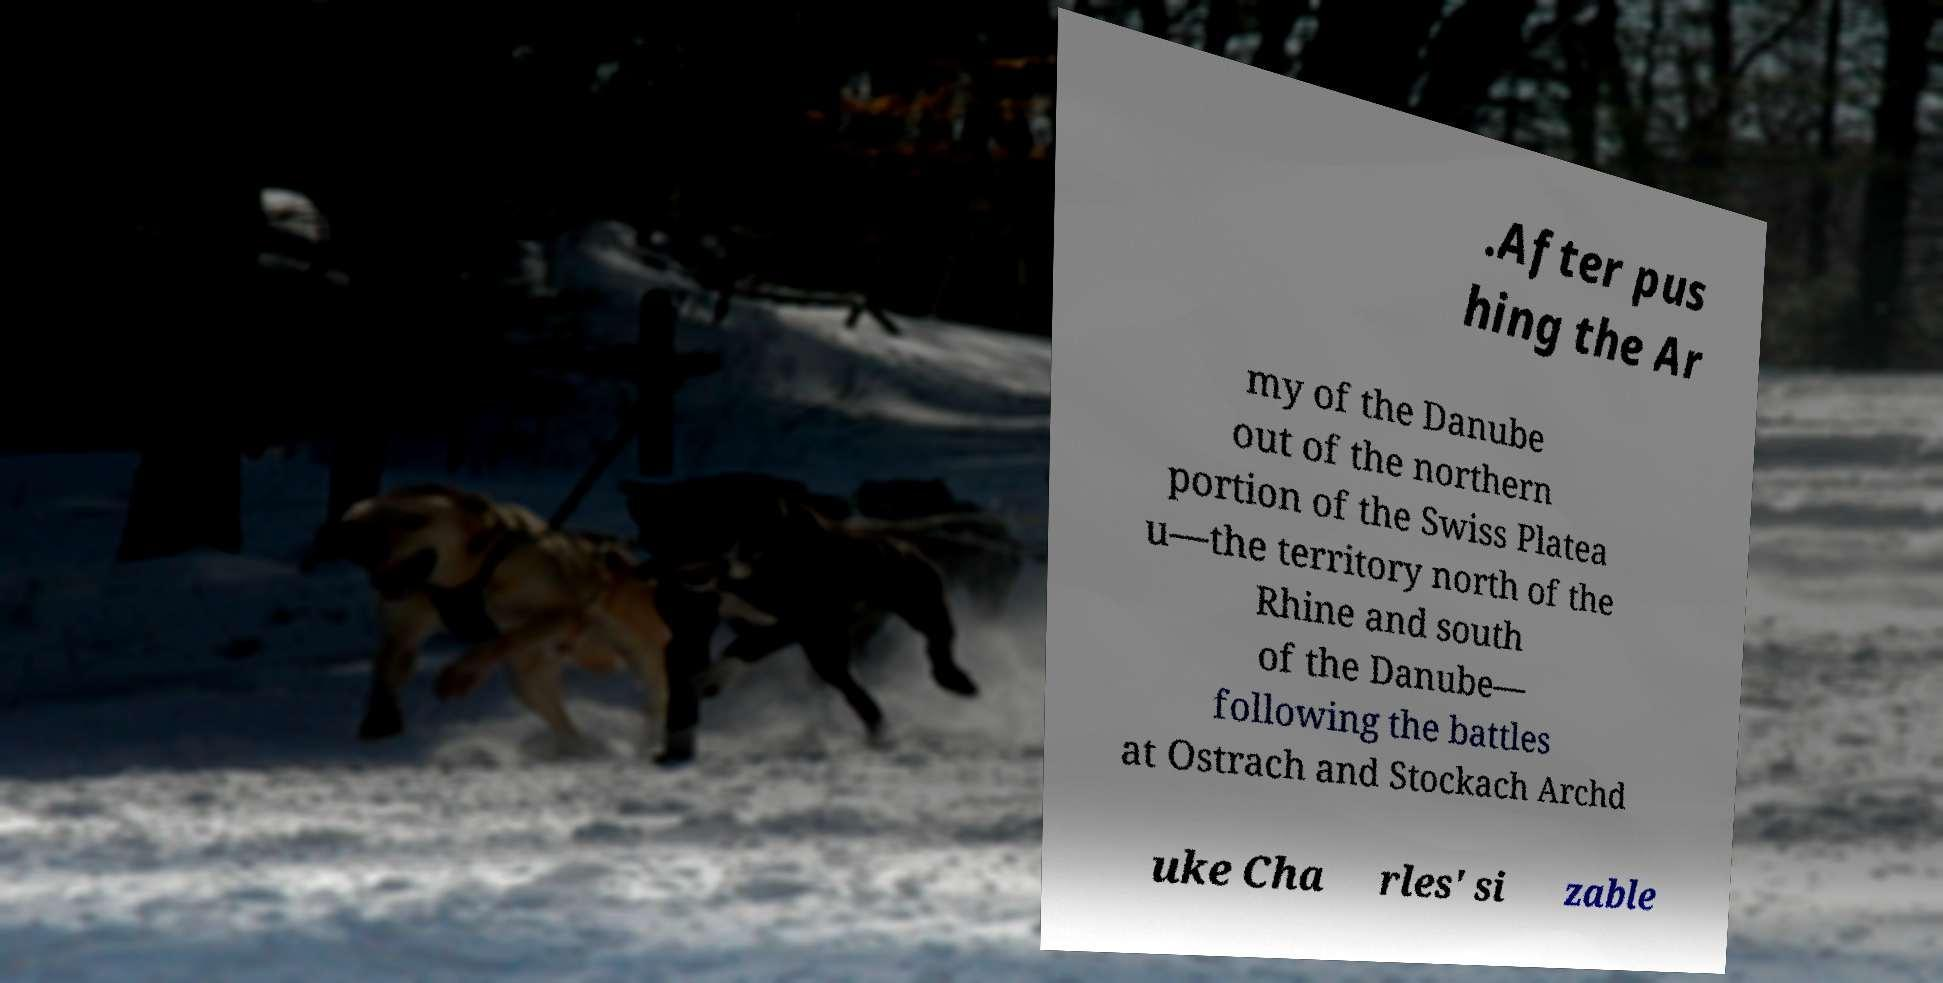Could you extract and type out the text from this image? .After pus hing the Ar my of the Danube out of the northern portion of the Swiss Platea u—the territory north of the Rhine and south of the Danube— following the battles at Ostrach and Stockach Archd uke Cha rles' si zable 